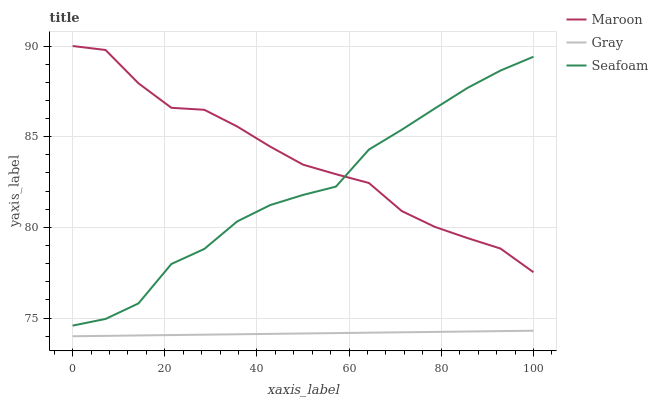Does Gray have the minimum area under the curve?
Answer yes or no. Yes. Does Maroon have the maximum area under the curve?
Answer yes or no. Yes. Does Seafoam have the minimum area under the curve?
Answer yes or no. No. Does Seafoam have the maximum area under the curve?
Answer yes or no. No. Is Gray the smoothest?
Answer yes or no. Yes. Is Seafoam the roughest?
Answer yes or no. Yes. Is Maroon the smoothest?
Answer yes or no. No. Is Maroon the roughest?
Answer yes or no. No. Does Gray have the lowest value?
Answer yes or no. Yes. Does Seafoam have the lowest value?
Answer yes or no. No. Does Maroon have the highest value?
Answer yes or no. Yes. Does Seafoam have the highest value?
Answer yes or no. No. Is Gray less than Maroon?
Answer yes or no. Yes. Is Seafoam greater than Gray?
Answer yes or no. Yes. Does Maroon intersect Seafoam?
Answer yes or no. Yes. Is Maroon less than Seafoam?
Answer yes or no. No. Is Maroon greater than Seafoam?
Answer yes or no. No. Does Gray intersect Maroon?
Answer yes or no. No. 